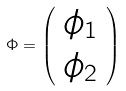<formula> <loc_0><loc_0><loc_500><loc_500>\Phi = \left ( \begin{array} { c } \phi _ { 1 } \\ \phi _ { 2 } \end{array} \right )</formula> 